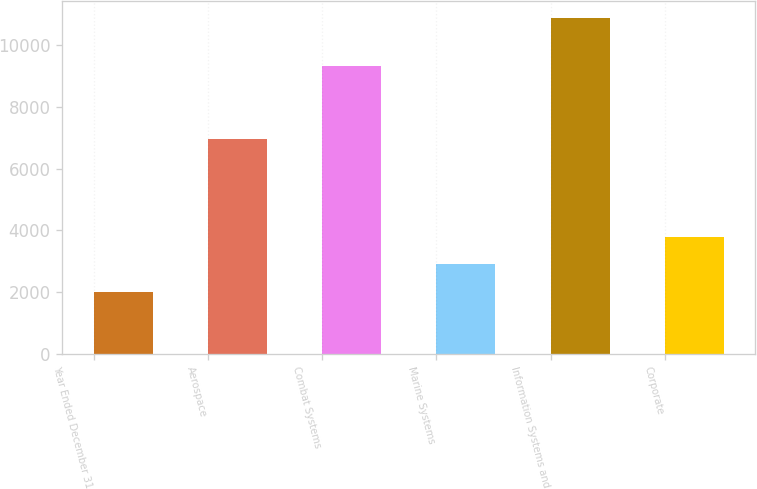Convert chart. <chart><loc_0><loc_0><loc_500><loc_500><bar_chart><fcel>Year Ended December 31<fcel>Aerospace<fcel>Combat Systems<fcel>Marine Systems<fcel>Information Systems and<fcel>Corporate<nl><fcel>2010<fcel>6963<fcel>9324<fcel>2898.8<fcel>10898<fcel>3787.6<nl></chart> 